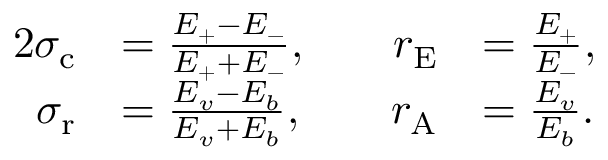Convert formula to latex. <formula><loc_0><loc_0><loc_500><loc_500>\begin{array} { r l r l } { { 2 } \sigma _ { c } } & { = \frac { E _ { + } - E _ { - } } { E _ { + } + E _ { - } } , \quad } & { r _ { E } } & { = \frac { E _ { + } } { E _ { - } } , } \\ { \sigma _ { r } } & { = \frac { E _ { v } - E _ { b } } { E _ { v } + E _ { b } } , } & { r _ { A } } & { = \frac { E _ { v } } { E _ { b } } . } \end{array}</formula> 